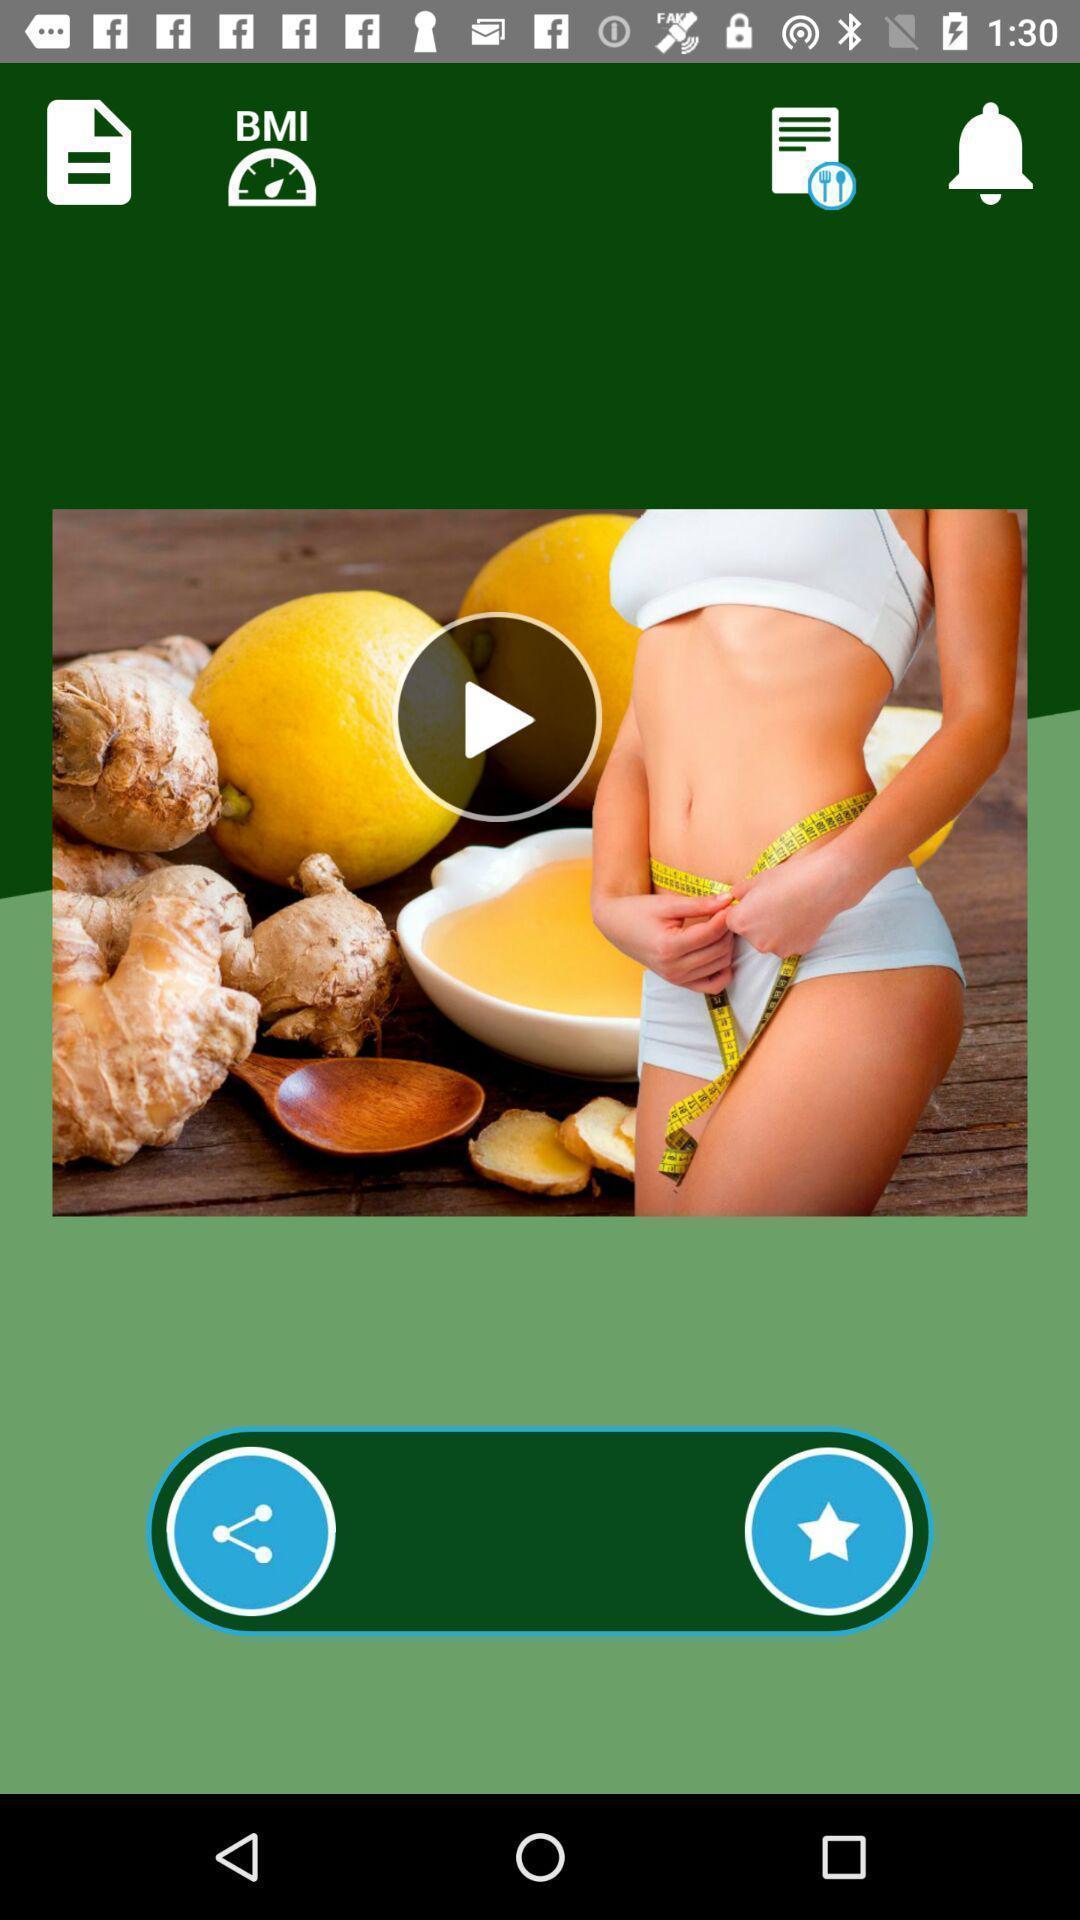Provide a description of this screenshot. Video is displaying in a healthcare application. 